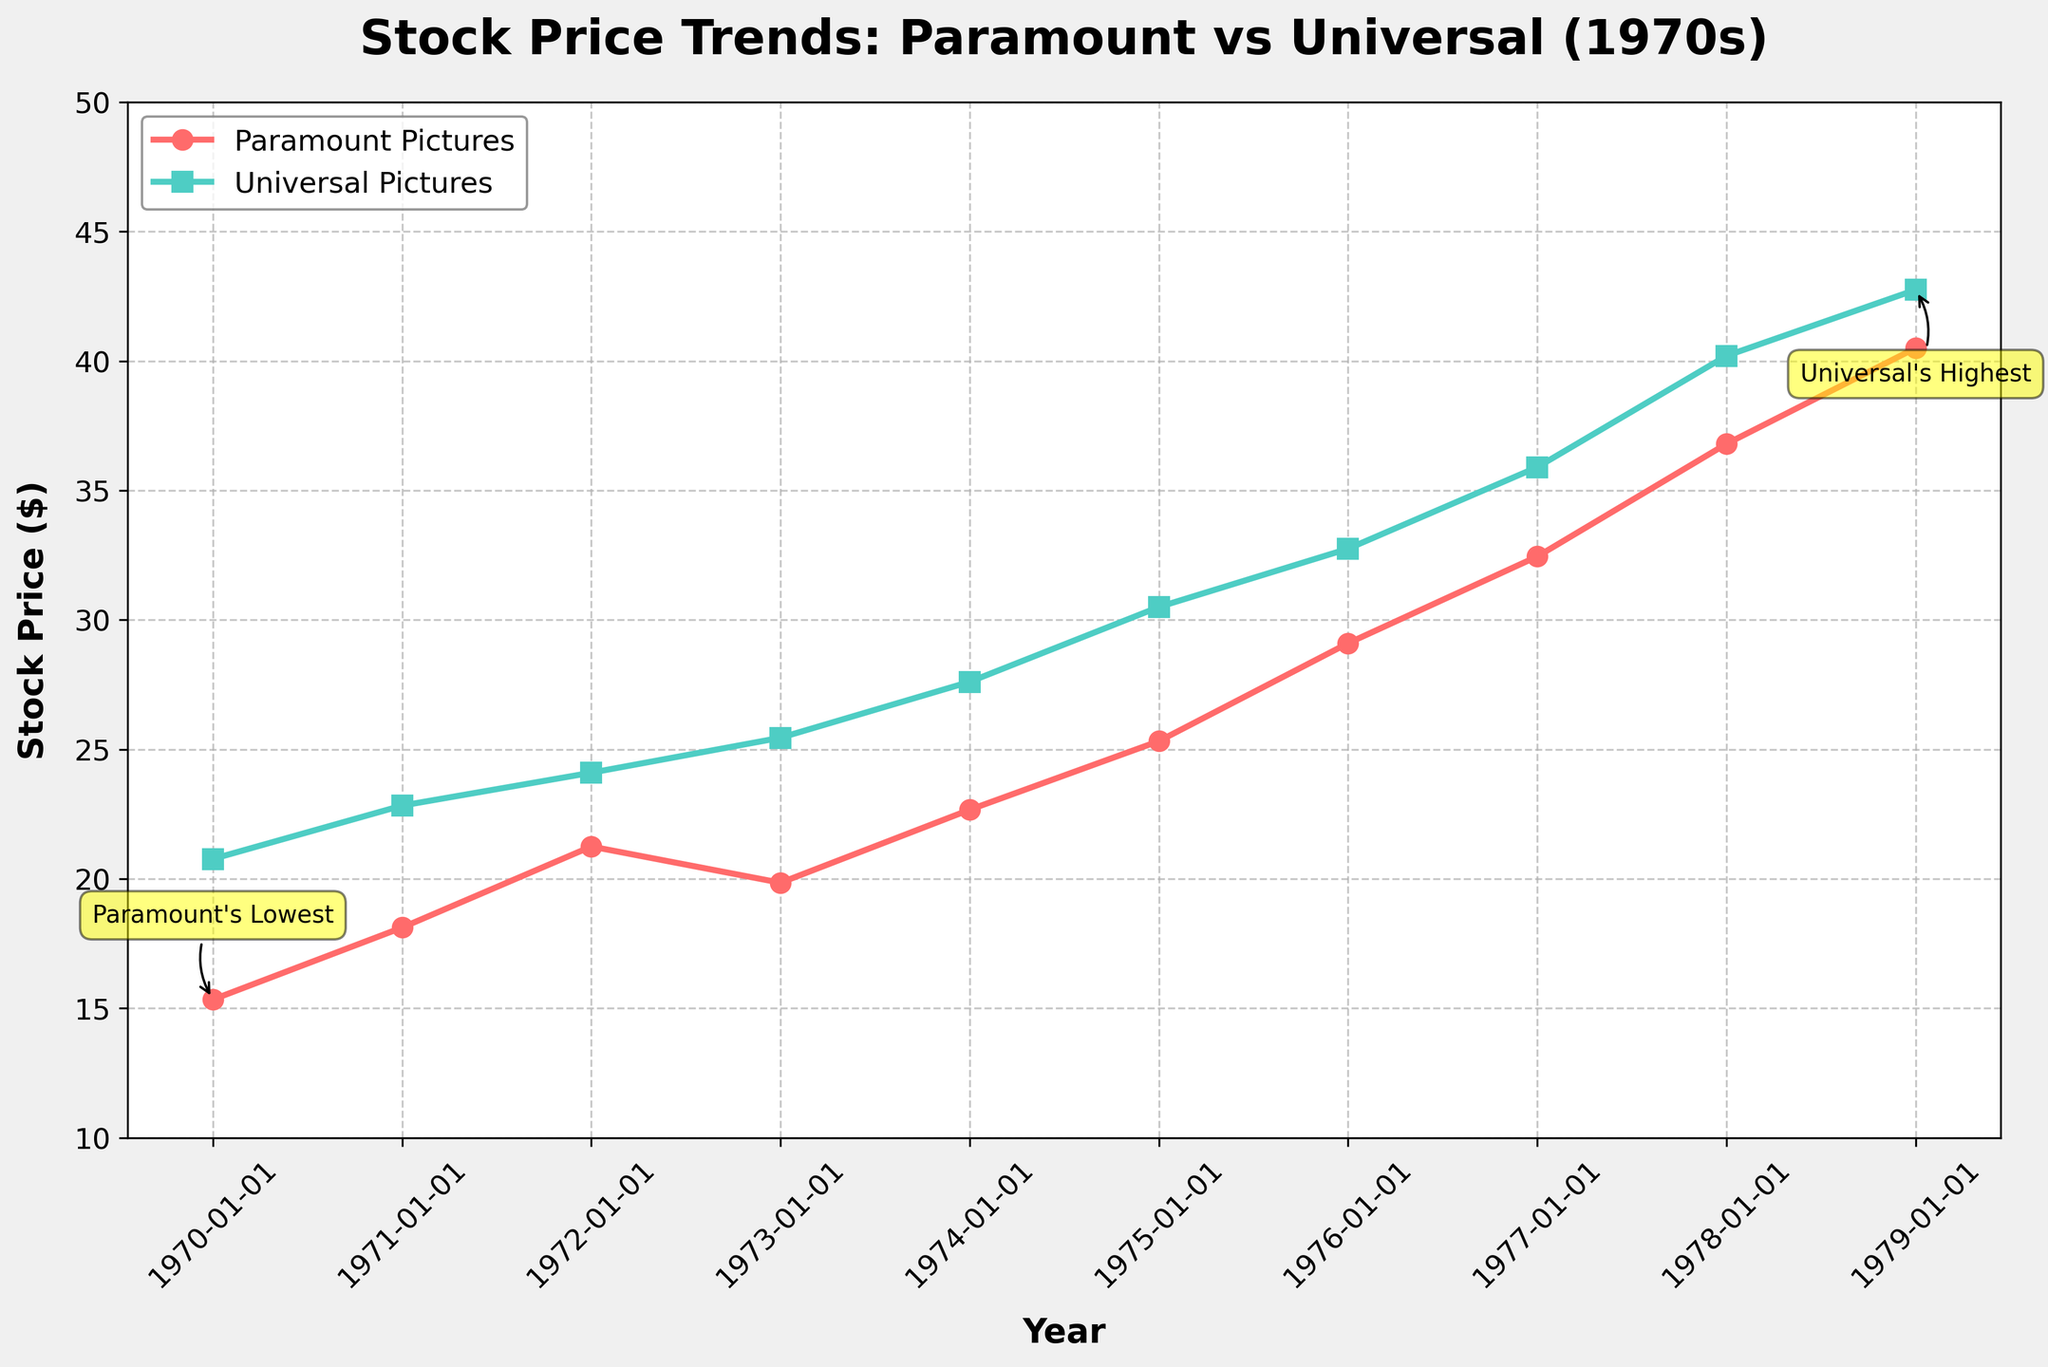what is the title of the plot? The title is typically positioned at the top of the plot. It provides a brief summary of what is being visualized. Observing the figure, the title of the plot is "Stock Price Trends: Paramount vs Universal (1970s)".
Answer: Stock Price Trends: Paramount vs Universal (1970s) what is the color used to represent Universal Pictures' stock price? In the figure, colors help to differentiate between the data series. Universal Pictures' stock price is represented by the color. The line and markers for Universal Pictures are colored teal.
Answer: Teal which company had a higher stock price in 1975? To determine this, we need to compare the stock prices of both companies in 1975 by checking the data points for that year. Paramount Pictures is shown to have a stock price of $25.32, while Universal Pictures has a stock price of $30.50. Universal Pictures had a higher stock price.
Answer: Universal Pictures what is the range of stock prices for Paramount Pictures throughout the 1970s? The range is the difference between the maximum and minimum stock prices. The lowest stock price for Paramount Pictures is $15.34 (1970), and the highest is $40.50 (1979). Therefore, the range is 40.50 - 15.34.
Answer: $25.16 in which year did Universal Pictures reach its highest stock price? Referring to the figure, we can observe the annotation and the data points to find Universal Pictures' highest stock price. It reached its highest stock price of $42.75 in 1979.
Answer: 1979 by how much did Paramount Pictures' stock price increase from 1976 to 1977? To find the increase, subtract the 1976 stock price from the 1977 stock price for Paramount Pictures. From the figure,1 Paramount Pictures' stock price was $29.10 in 1976 and $32.45 in 1977. The increase is 32.45 - 29.10.
Answer: $3.35 how many distinct data points (years) are plotted for each company? Counting the markers on the plot can give the number of data points for each company. The figure shows data points for each year from 1970 to 1979, making 10 distinct data points per company.
Answer: 10 which company had a greater overall increase in stock price between 1970 and 1979? We need to calculate the overall increase for both companies from 1970 to 1979 by subtracting the initial stock price from the final stock price. For Paramount Pictures: 40.50 - 15.34 = 25.16. For Universal Pictures: 42.75 - 20.77 = 21.98. Comparing these increases, Paramount Pictures had a greater overall increase.
Answer: Paramount Pictures 